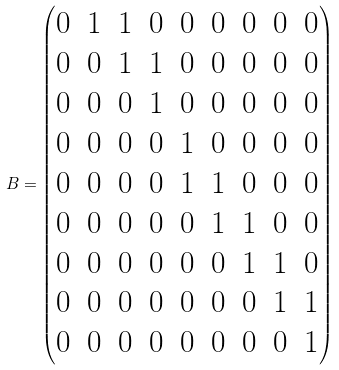<formula> <loc_0><loc_0><loc_500><loc_500>B = \begin{pmatrix} 0 & 1 & 1 & 0 & 0 & 0 & 0 & 0 & 0 \\ 0 & 0 & 1 & 1 & 0 & 0 & 0 & 0 & 0 \\ 0 & 0 & 0 & 1 & 0 & 0 & 0 & 0 & 0 \\ 0 & 0 & 0 & 0 & 1 & 0 & 0 & 0 & 0 \\ 0 & 0 & 0 & 0 & 1 & 1 & 0 & 0 & 0 \\ 0 & 0 & 0 & 0 & 0 & 1 & 1 & 0 & 0 \\ 0 & 0 & 0 & 0 & 0 & 0 & 1 & 1 & 0 \\ 0 & 0 & 0 & 0 & 0 & 0 & 0 & 1 & 1 \\ 0 & 0 & 0 & 0 & 0 & 0 & 0 & 0 & 1 \end{pmatrix}</formula> 